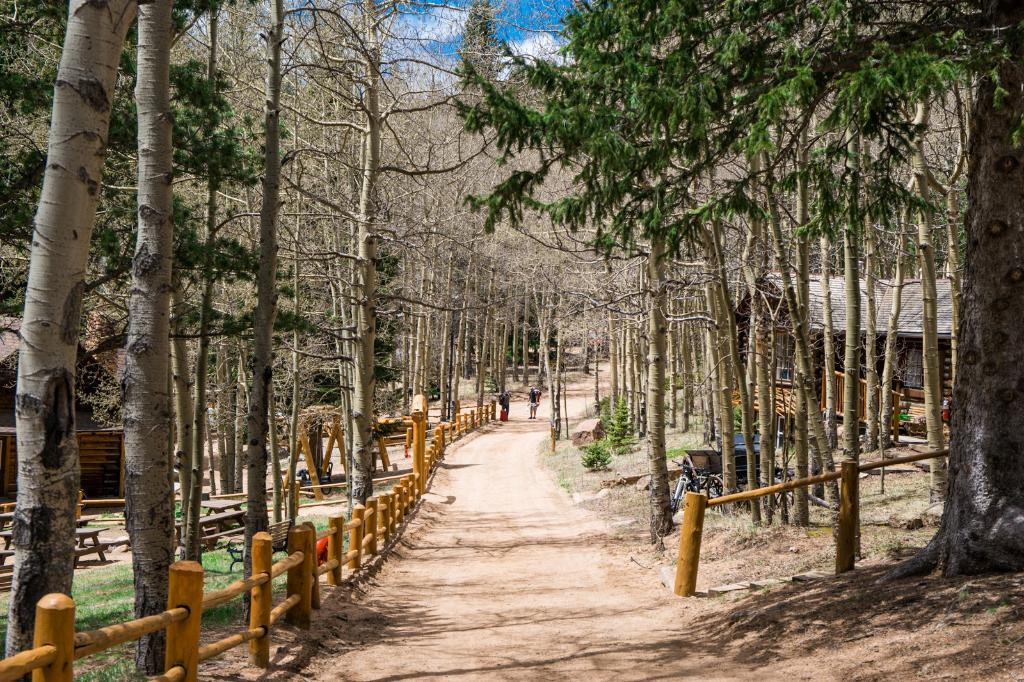What type of vegetation can be seen in the image? There are trees in the image. What type of barrier is present in the image? There is fencing in the image. What type of seating is available in the image? There are benches in the image. What type of structures are visible in the image? There are wooden houses in the image. How would you describe the sky in the image? The sky is clouded in the image. How many mice are playing on the benches in the image? There are no mice present in the image; it features trees, fencing, benches, wooden houses, and a clouded sky. What is the relationship between the two brothers in the image? There is no mention of any brothers in the image. 